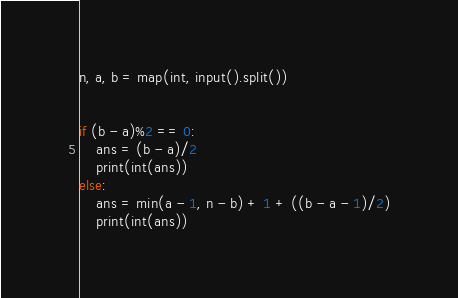<code> <loc_0><loc_0><loc_500><loc_500><_Python_>n, a, b = map(int, input().split())


if (b - a)%2 == 0:
    ans = (b - a)/2
    print(int(ans))
else:
    ans = min(a - 1, n - b) + 1 + ((b - a - 1)/2)
    print(int(ans))
</code> 